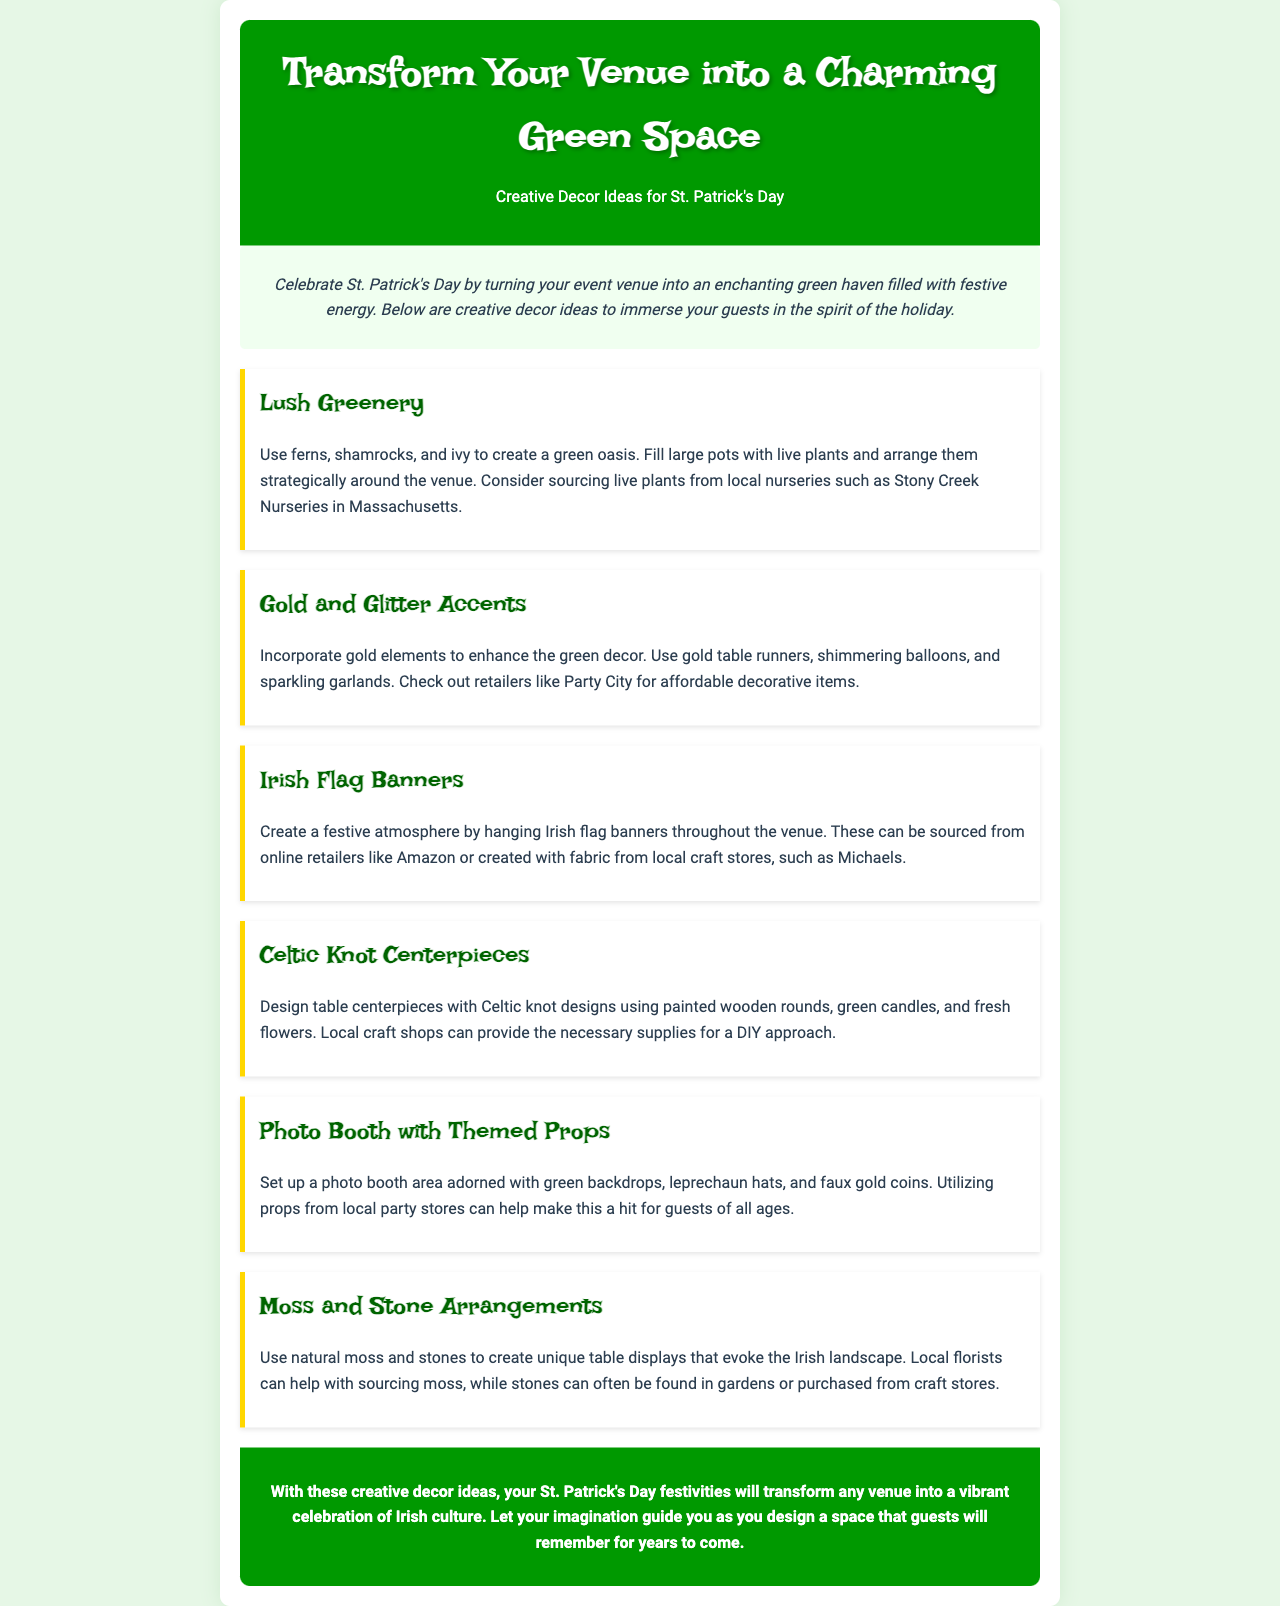What is the title of the newsletter? The title of the newsletter is prominently displayed at the top of the document.
Answer: Transform Your Venue into a Charming Green Space What is a suggested plant for the decor? The document lists specific plants to create a green oasis, highlighting ferns and shamrocks.
Answer: Ferns Where can you source Irish flag banners? The document mentions specific retailers where Irish flag banners can be acquired.
Answer: Amazon What decorative accent is suggested to complement the green decor? The document emphasizes incorporating a specific color element to enhance the green decor.
Answer: Gold What is included in the Moss and Stone Arrangements idea? The document describes what materials are used in a unique table display.
Answer: Moss and stones What is a recommended item for a photo booth? The document lists specific props that can be included in the photo booth setup.
Answer: Leprechaun hats What type of centerpieces are suggested? The document recommends a specific design for table centerpieces, notable for its cultural significance.
Answer: Celtic knot designs What color theme is prevalent in the decor ideas? The overall theme of the decorations focuses on a particular color related to St. Patrick's Day.
Answer: Green Which local shop is mentioned for sourcing craft materials? The document references a specific type of local store for obtaining needed craft supplies.
Answer: Michaels 